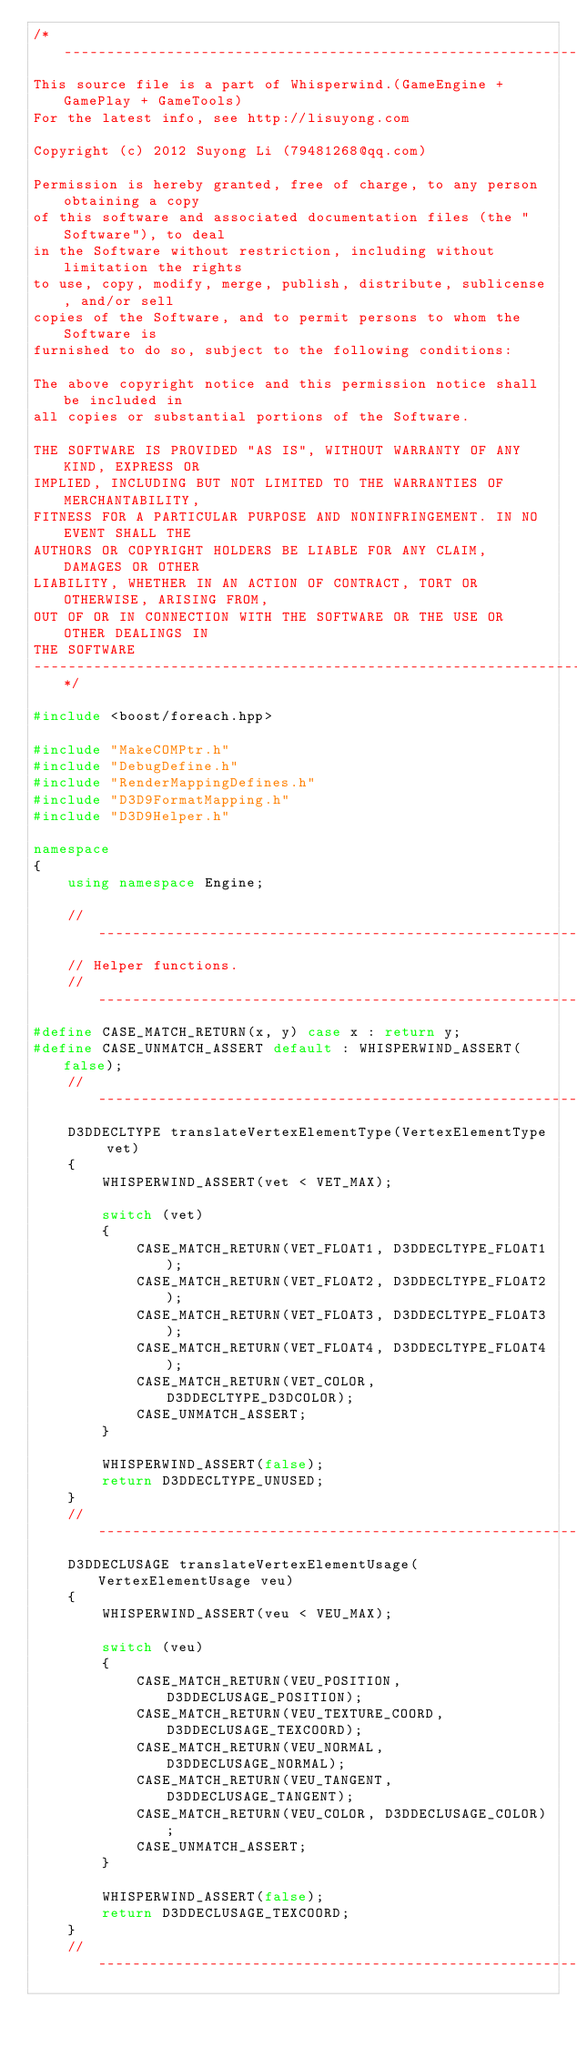Convert code to text. <code><loc_0><loc_0><loc_500><loc_500><_C++_>/*-------------------------------------------------------------------------
This source file is a part of Whisperwind.(GameEngine + GamePlay + GameTools)
For the latest info, see http://lisuyong.com

Copyright (c) 2012 Suyong Li (79481268@qq.com)

Permission is hereby granted, free of charge, to any person obtaining a copy
of this software and associated documentation files (the "Software"), to deal
in the Software without restriction, including without limitation the rights
to use, copy, modify, merge, publish, distribute, sublicense, and/or sell
copies of the Software, and to permit persons to whom the Software is
furnished to do so, subject to the following conditions:

The above copyright notice and this permission notice shall be included in
all copies or substantial portions of the Software.

THE SOFTWARE IS PROVIDED "AS IS", WITHOUT WARRANTY OF ANY KIND, EXPRESS OR
IMPLIED, INCLUDING BUT NOT LIMITED TO THE WARRANTIES OF MERCHANTABILITY,
FITNESS FOR A PARTICULAR PURPOSE AND NONINFRINGEMENT. IN NO EVENT SHALL THE
AUTHORS OR COPYRIGHT HOLDERS BE LIABLE FOR ANY CLAIM, DAMAGES OR OTHER
LIABILITY, WHETHER IN AN ACTION OF CONTRACT, TORT OR OTHERWISE, ARISING FROM,
OUT OF OR IN CONNECTION WITH THE SOFTWARE OR THE USE OR OTHER DEALINGS IN
THE SOFTWARE
-------------------------------------------------------------------------*/

#include <boost/foreach.hpp>

#include "MakeCOMPtr.h"
#include "DebugDefine.h"
#include "RenderMappingDefines.h"
#include "D3D9FormatMapping.h"
#include "D3D9Helper.h"

namespace
{
	using namespace Engine;

	//---------------------------------------------------------------------
	// Helper functions.
	//---------------------------------------------------------------------
#define CASE_MATCH_RETURN(x, y) case x : return y;
#define CASE_UNMATCH_ASSERT default : WHISPERWIND_ASSERT(false);
	//---------------------------------------------------------------------
	D3DDECLTYPE translateVertexElementType(VertexElementType vet)
	{
		WHISPERWIND_ASSERT(vet < VET_MAX);

		switch (vet)
		{
			CASE_MATCH_RETURN(VET_FLOAT1, D3DDECLTYPE_FLOAT1);
			CASE_MATCH_RETURN(VET_FLOAT2, D3DDECLTYPE_FLOAT2);
			CASE_MATCH_RETURN(VET_FLOAT3, D3DDECLTYPE_FLOAT3);
			CASE_MATCH_RETURN(VET_FLOAT4, D3DDECLTYPE_FLOAT4);
			CASE_MATCH_RETURN(VET_COLOR, D3DDECLTYPE_D3DCOLOR);
			CASE_UNMATCH_ASSERT;
		}

		WHISPERWIND_ASSERT(false);
		return D3DDECLTYPE_UNUSED;
	}
	//---------------------------------------------------------------------
	D3DDECLUSAGE translateVertexElementUsage(VertexElementUsage veu)
	{
		WHISPERWIND_ASSERT(veu < VEU_MAX);

		switch (veu)
		{
			CASE_MATCH_RETURN(VEU_POSITION, D3DDECLUSAGE_POSITION);
			CASE_MATCH_RETURN(VEU_TEXTURE_COORD, D3DDECLUSAGE_TEXCOORD);
			CASE_MATCH_RETURN(VEU_NORMAL, D3DDECLUSAGE_NORMAL);
			CASE_MATCH_RETURN(VEU_TANGENT, D3DDECLUSAGE_TANGENT);
			CASE_MATCH_RETURN(VEU_COLOR, D3DDECLUSAGE_COLOR);
			CASE_UNMATCH_ASSERT;
		}

		WHISPERWIND_ASSERT(false);
		return D3DDECLUSAGE_TEXCOORD;
	}
	//---------------------------------------------------------------------</code> 